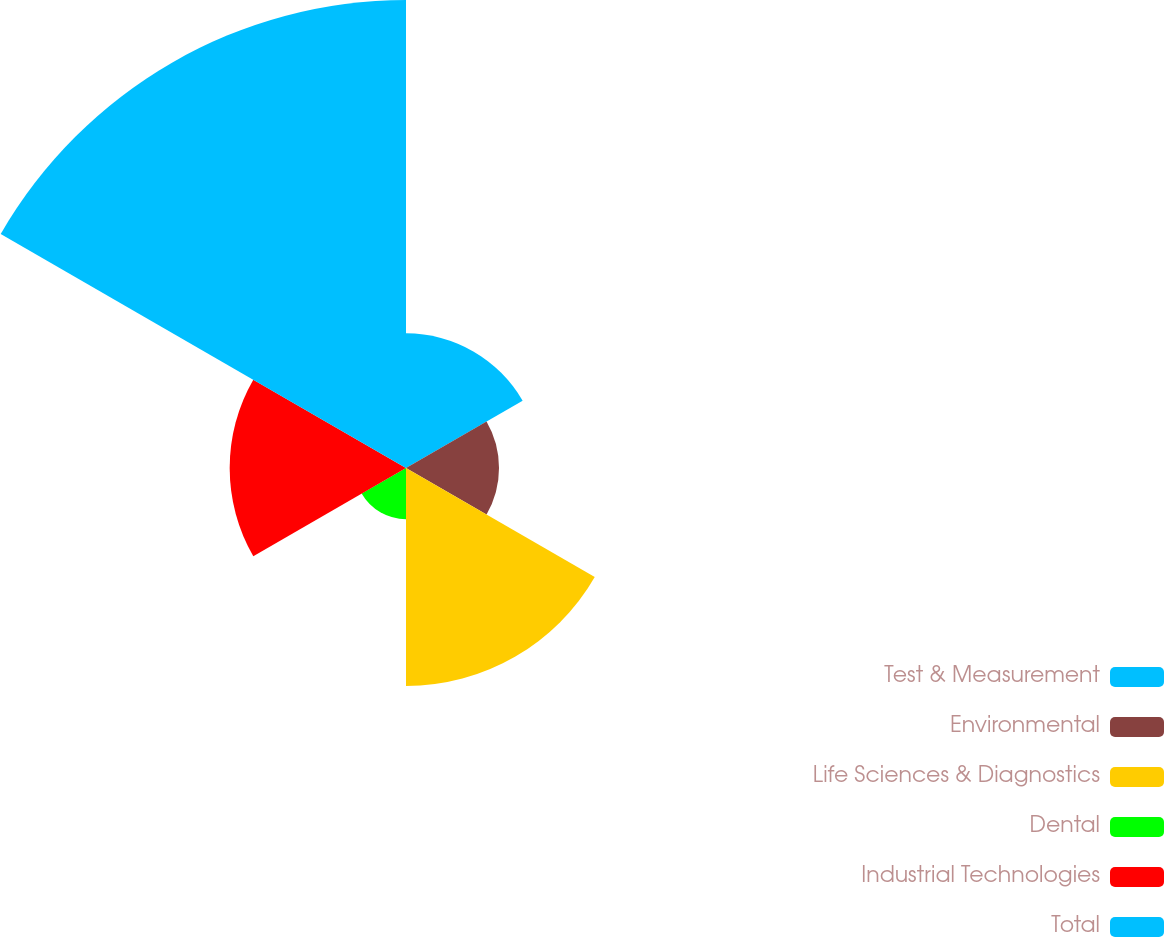Convert chart. <chart><loc_0><loc_0><loc_500><loc_500><pie_chart><fcel>Test & Measurement<fcel>Environmental<fcel>Life Sciences & Diagnostics<fcel>Dental<fcel>Industrial Technologies<fcel>Total<nl><fcel>11.8%<fcel>8.15%<fcel>19.1%<fcel>4.49%<fcel>15.45%<fcel>41.01%<nl></chart> 